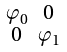<formula> <loc_0><loc_0><loc_500><loc_500>\begin{smallmatrix} \varphi _ { 0 } & 0 \\ 0 & \varphi _ { 1 } \end{smallmatrix}</formula> 